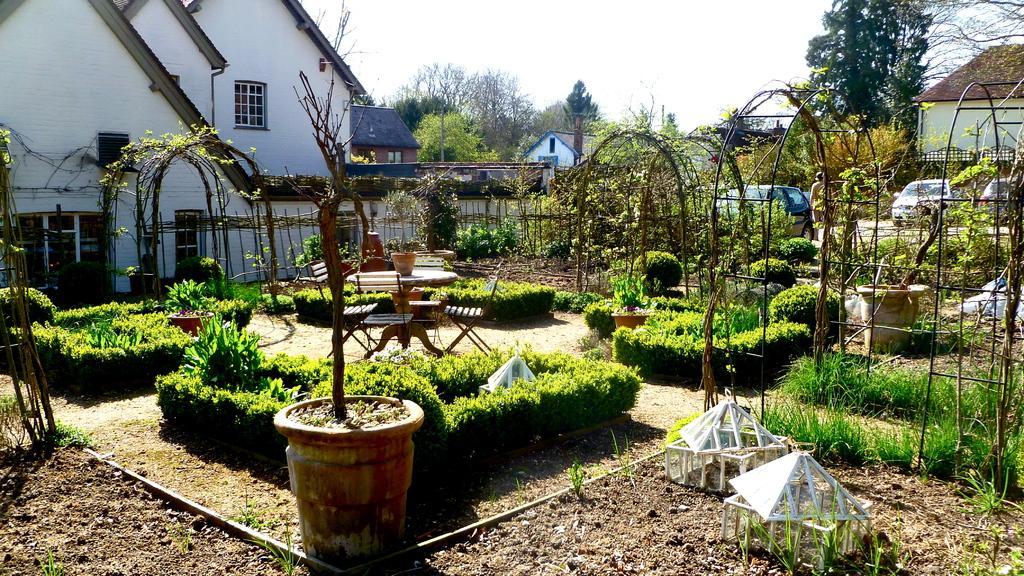Describe this image in one or two sentences. In the background we can see the sky. In this picture we can see the houses, trees, plants, pots, chairs, fence and few objects. On the right side of the picture we can see vehicles and we can see a person wearing a hat. 